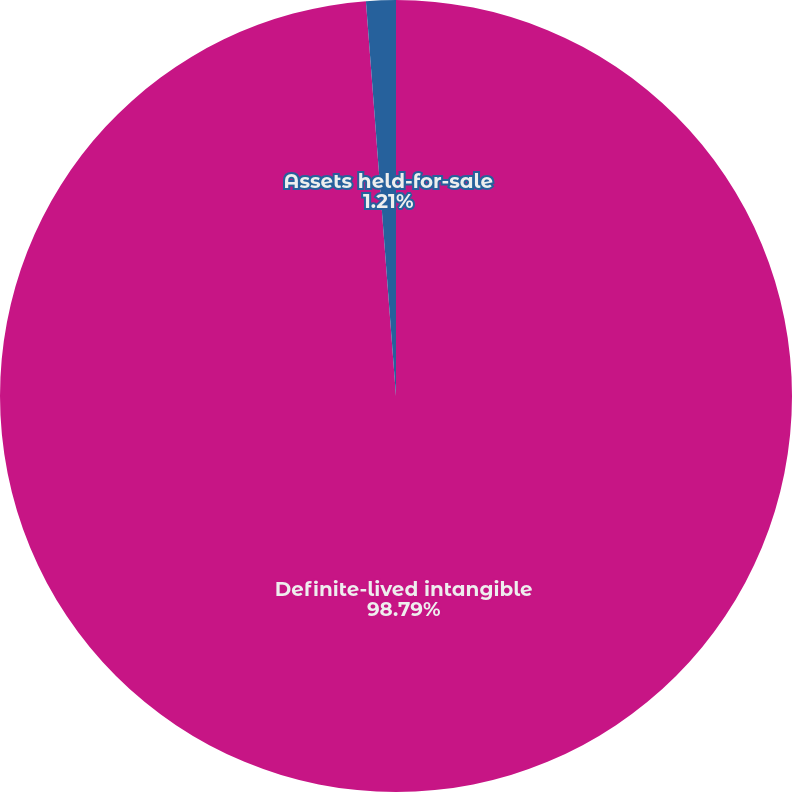Convert chart to OTSL. <chart><loc_0><loc_0><loc_500><loc_500><pie_chart><fcel>Definite-lived intangible<fcel>Assets held-for-sale<nl><fcel>98.79%<fcel>1.21%<nl></chart> 